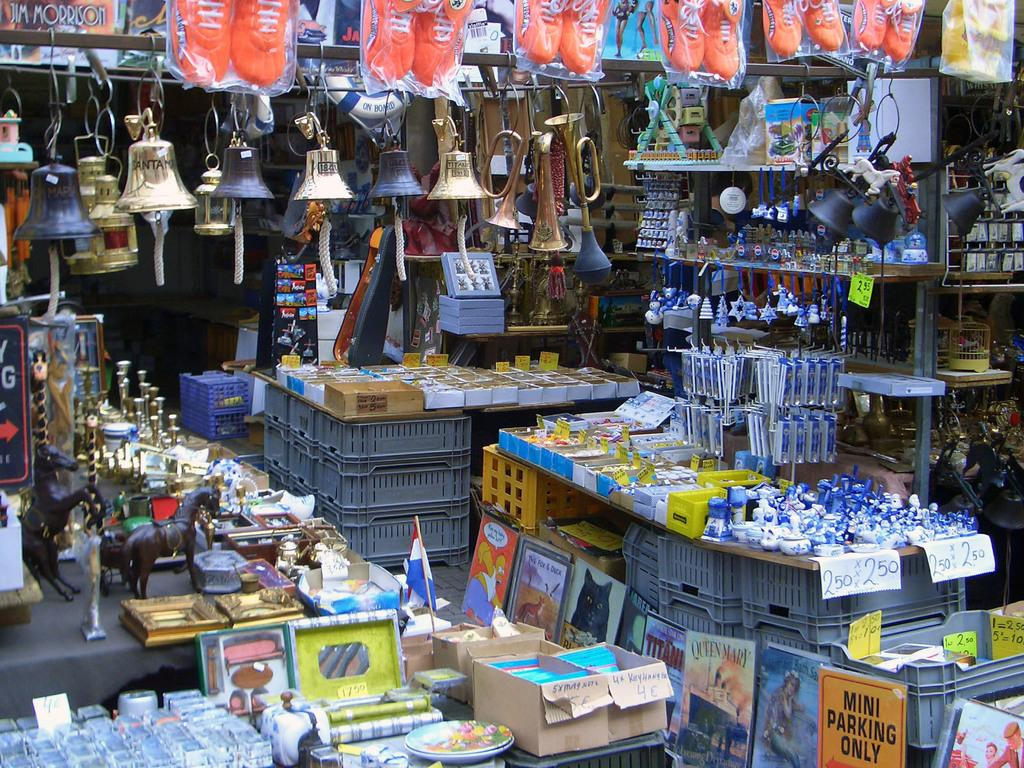<image>
Share a concise interpretation of the image provided. Among other items sold in this booth are a sign that advertises the Queen Mary and another featuring Homer Simpson. 